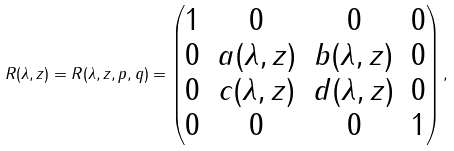<formula> <loc_0><loc_0><loc_500><loc_500>R ( \lambda , z ) = R ( \lambda , z , p , q ) = \begin{pmatrix} 1 & 0 & 0 & 0 \\ 0 & a ( \lambda , z ) & b ( \lambda , z ) & 0 \\ 0 & c ( \lambda , z ) & d ( \lambda , z ) & 0 \\ 0 & 0 & 0 & 1 \end{pmatrix} ,</formula> 